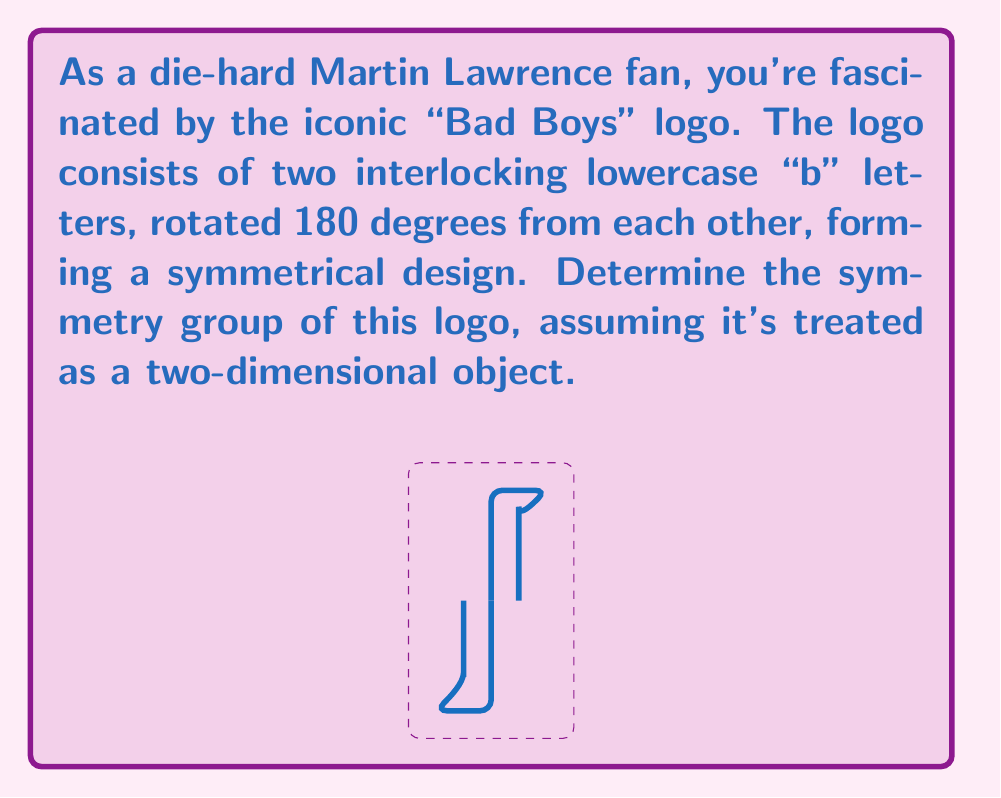Can you answer this question? To determine the symmetry group of the "Bad Boys" logo, we need to identify all the symmetry operations that leave the logo unchanged. Let's analyze step-by-step:

1. Rotational symmetry:
   - The logo remains unchanged when rotated 180° around its center.
   - This is equivalent to a rotation of order 2.

2. Reflection symmetry:
   - The logo has two lines of reflection:
     a. Vertical line through the center
     b. Horizontal line through the center

3. Identity:
   - The identity operation (doing nothing) is always a symmetry.

These symmetries form a group under composition. Let's define the elements:
- $e$: identity
- $r$: rotation by 180°
- $h$: reflection across the horizontal axis
- $v$: reflection across the vertical axis

We can verify that these form a group:
- Closure: Composing any two elements results in another element of the set.
- Associativity: Composition of symmetries is always associative.
- Identity: $e$ is the identity element.
- Inverse: Each element is its own inverse ($r^2 = h^2 = v^2 = e$).

The group table for these symmetries is:

$$\begin{array}{c|cccc}
    & e & r & h & v \\
\hline
e   & e & r & h & v \\
r   & r & e & v & h \\
h   & h & v & e & r \\
v   & v & h & r & e
\end{array}$$

This group structure is isomorphic to the Klein four-group, also known as $V_4$ or $C_2 \times C_2$.
Answer: $V_4$ (Klein four-group) 